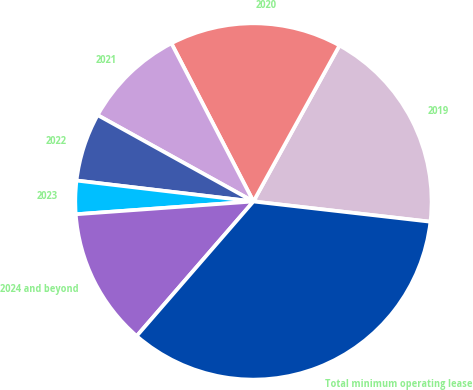Convert chart. <chart><loc_0><loc_0><loc_500><loc_500><pie_chart><fcel>2019<fcel>2020<fcel>2021<fcel>2022<fcel>2023<fcel>2024 and beyond<fcel>Total minimum operating lease<nl><fcel>18.79%<fcel>15.64%<fcel>9.33%<fcel>6.18%<fcel>3.02%<fcel>12.48%<fcel>34.56%<nl></chart> 